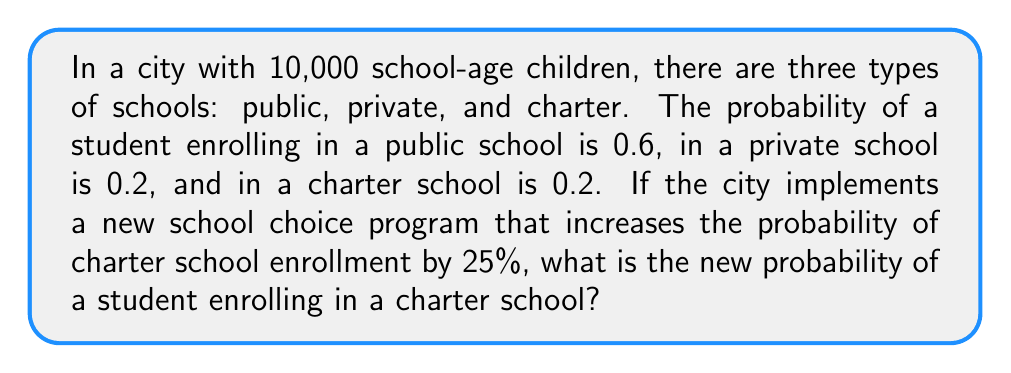What is the answer to this math problem? Let's approach this step-by-step:

1) Initially, the probabilities are:
   Public school: $P(public) = 0.6$
   Private school: $P(private) = 0.2$
   Charter school: $P(charter) = 0.2$

2) The new program increases the probability of charter school enrollment by 25%.
   To calculate this, we multiply the original probability by 1.25:

   $P_{new}(charter) = P(charter) \times 1.25 = 0.2 \times 1.25 = 0.25$

3) However, we need to ensure that the total probability across all school types still equals 1.
   Currently, we have:
   $P(public) + P(private) + P_{new}(charter) = 0.6 + 0.2 + 0.25 = 1.05$

4) To normalize this, we need to scale all probabilities by a factor that will make them sum to 1.
   Let's call this factor $k$. We can find $k$ by solving:

   $k(0.6 + 0.2 + 0.25) = 1$
   $k(1.05) = 1$
   $k = \frac{1}{1.05} \approx 0.9524$

5) Now, we can calculate the new probability for charter school enrollment:

   $P_{final}(charter) = 0.25 \times 0.9524 \approx 0.2381$

Therefore, the new probability of a student enrolling in a charter school is approximately 0.2381 or 23.81%.
Answer: 0.2381 